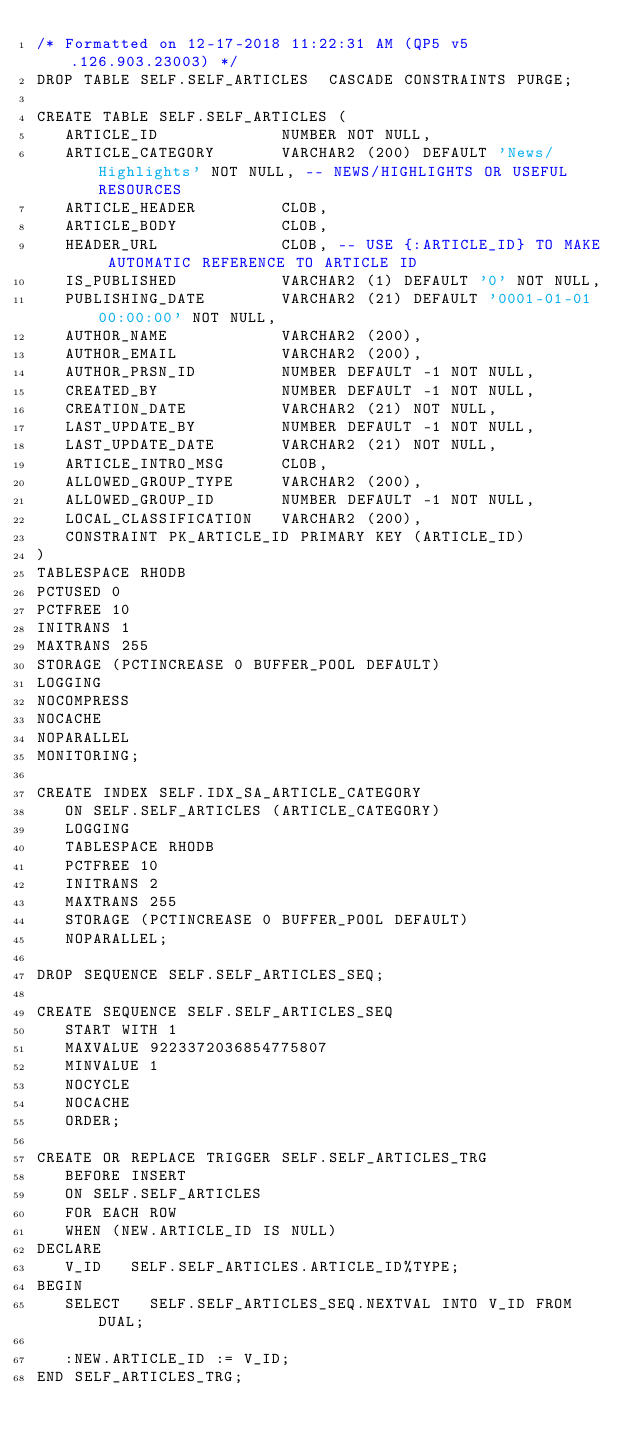Convert code to text. <code><loc_0><loc_0><loc_500><loc_500><_SQL_>/* Formatted on 12-17-2018 11:22:31 AM (QP5 v5.126.903.23003) */
DROP TABLE SELF.SELF_ARTICLES  CASCADE CONSTRAINTS PURGE;

CREATE TABLE SELF.SELF_ARTICLES (
   ARTICLE_ID             NUMBER NOT NULL,
   ARTICLE_CATEGORY       VARCHAR2 (200) DEFAULT 'News/Highlights' NOT NULL, -- NEWS/HIGHLIGHTS OR USEFUL RESOURCES
   ARTICLE_HEADER         CLOB,
   ARTICLE_BODY           CLOB,
   HEADER_URL             CLOB, -- USE {:ARTICLE_ID} TO MAKE AUTOMATIC REFERENCE TO ARTICLE ID
   IS_PUBLISHED           VARCHAR2 (1) DEFAULT '0' NOT NULL,
   PUBLISHING_DATE        VARCHAR2 (21) DEFAULT '0001-01-01 00:00:00' NOT NULL,
   AUTHOR_NAME            VARCHAR2 (200),
   AUTHOR_EMAIL           VARCHAR2 (200),
   AUTHOR_PRSN_ID         NUMBER DEFAULT -1 NOT NULL,
   CREATED_BY             NUMBER DEFAULT -1 NOT NULL,
   CREATION_DATE          VARCHAR2 (21) NOT NULL,
   LAST_UPDATE_BY         NUMBER DEFAULT -1 NOT NULL,
   LAST_UPDATE_DATE       VARCHAR2 (21) NOT NULL,
   ARTICLE_INTRO_MSG      CLOB,
   ALLOWED_GROUP_TYPE     VARCHAR2 (200),
   ALLOWED_GROUP_ID       NUMBER DEFAULT -1 NOT NULL,
   LOCAL_CLASSIFICATION   VARCHAR2 (200),
   CONSTRAINT PK_ARTICLE_ID PRIMARY KEY (ARTICLE_ID)
)
TABLESPACE RHODB
PCTUSED 0
PCTFREE 10
INITRANS 1
MAXTRANS 255
STORAGE (PCTINCREASE 0 BUFFER_POOL DEFAULT)
LOGGING
NOCOMPRESS
NOCACHE
NOPARALLEL
MONITORING;

CREATE INDEX SELF.IDX_SA_ARTICLE_CATEGORY
   ON SELF.SELF_ARTICLES (ARTICLE_CATEGORY)
   LOGGING
   TABLESPACE RHODB
   PCTFREE 10
   INITRANS 2
   MAXTRANS 255
   STORAGE (PCTINCREASE 0 BUFFER_POOL DEFAULT)
   NOPARALLEL;

DROP SEQUENCE SELF.SELF_ARTICLES_SEQ;

CREATE SEQUENCE SELF.SELF_ARTICLES_SEQ
   START WITH 1
   MAXVALUE 9223372036854775807
   MINVALUE 1
   NOCYCLE
   NOCACHE
   ORDER;

CREATE OR REPLACE TRIGGER SELF.SELF_ARTICLES_TRG
   BEFORE INSERT
   ON SELF.SELF_ARTICLES
   FOR EACH ROW
   WHEN (NEW.ARTICLE_ID IS NULL)
DECLARE
   V_ID   SELF.SELF_ARTICLES.ARTICLE_ID%TYPE;
BEGIN
   SELECT   SELF.SELF_ARTICLES_SEQ.NEXTVAL INTO V_ID FROM DUAL;

   :NEW.ARTICLE_ID := V_ID;
END SELF_ARTICLES_TRG;</code> 